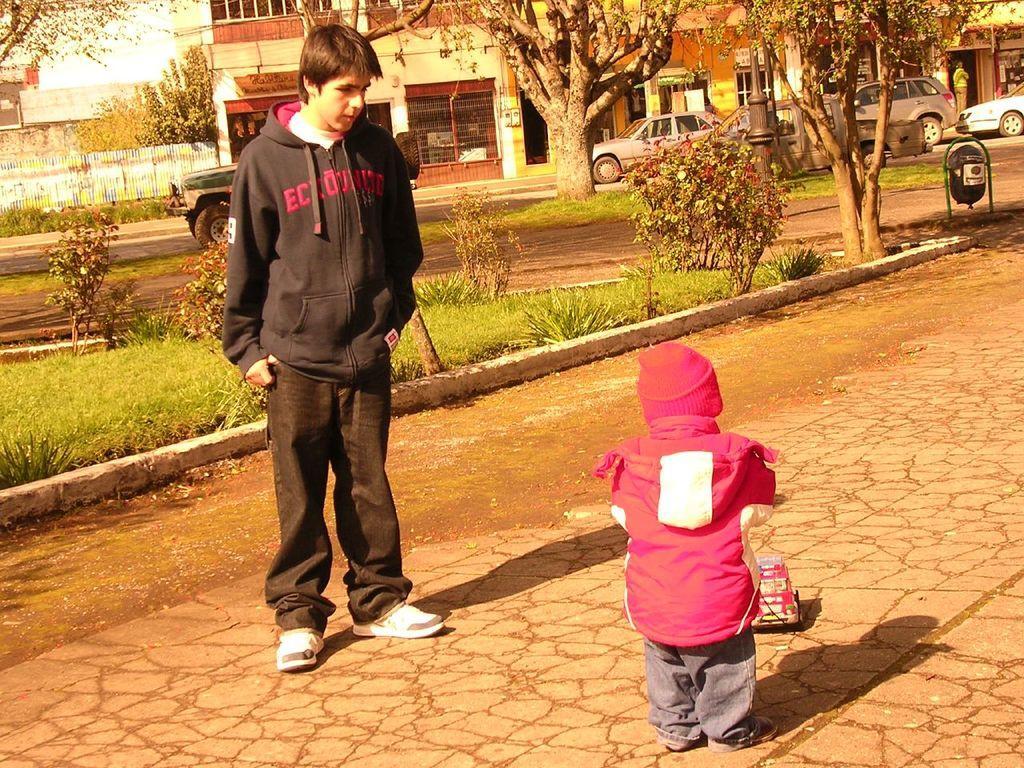Please provide a concise description of this image. In this picture we can see a man, child, toy vehicle on the ground and in the background we can see plants, vehicles, dustbin, trees, buildings, person and some objects. 